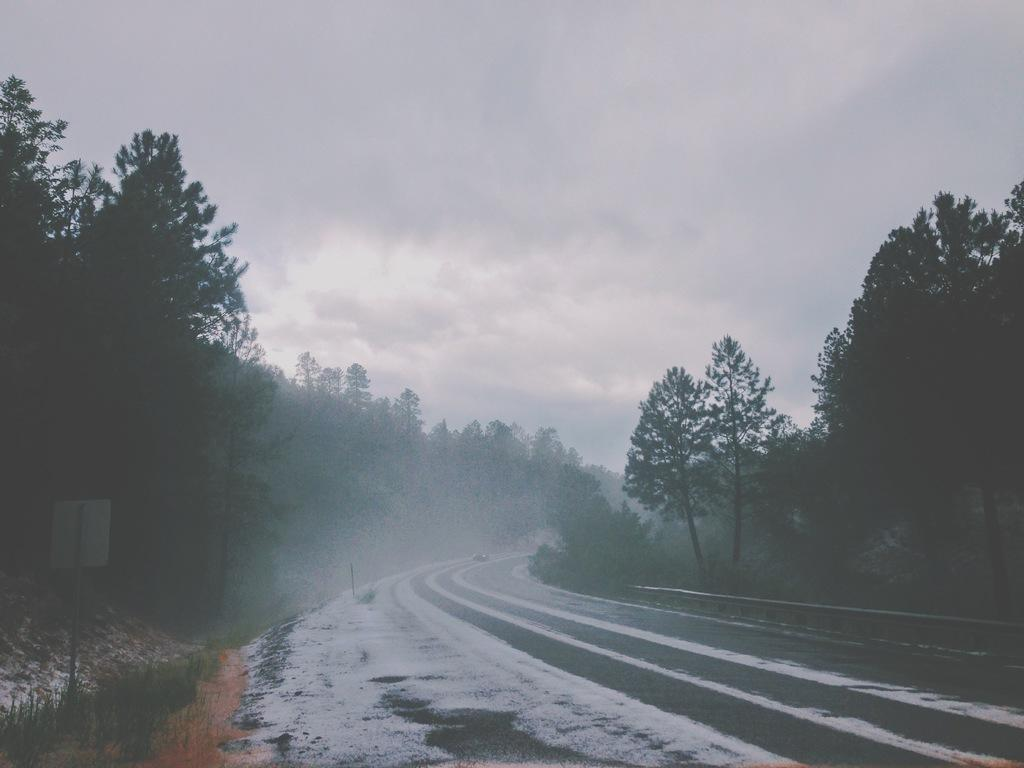What type of vegetation can be seen in the image? There are trees in the image. What is covering the road in the image? There is snow on the road in the image. What can be seen in the background of the image? The sky is visible in the background of the image. Can you describe the board attached to a pole in the image? Yes, there is a board attached to a pole at the bottom left side of the image. Where is the cactus located in the image? There is no cactus present in the image. What type of control is being exercised over the snow in the image? There is no control being exercised over the snow in the image; it is a natural occurrence. 